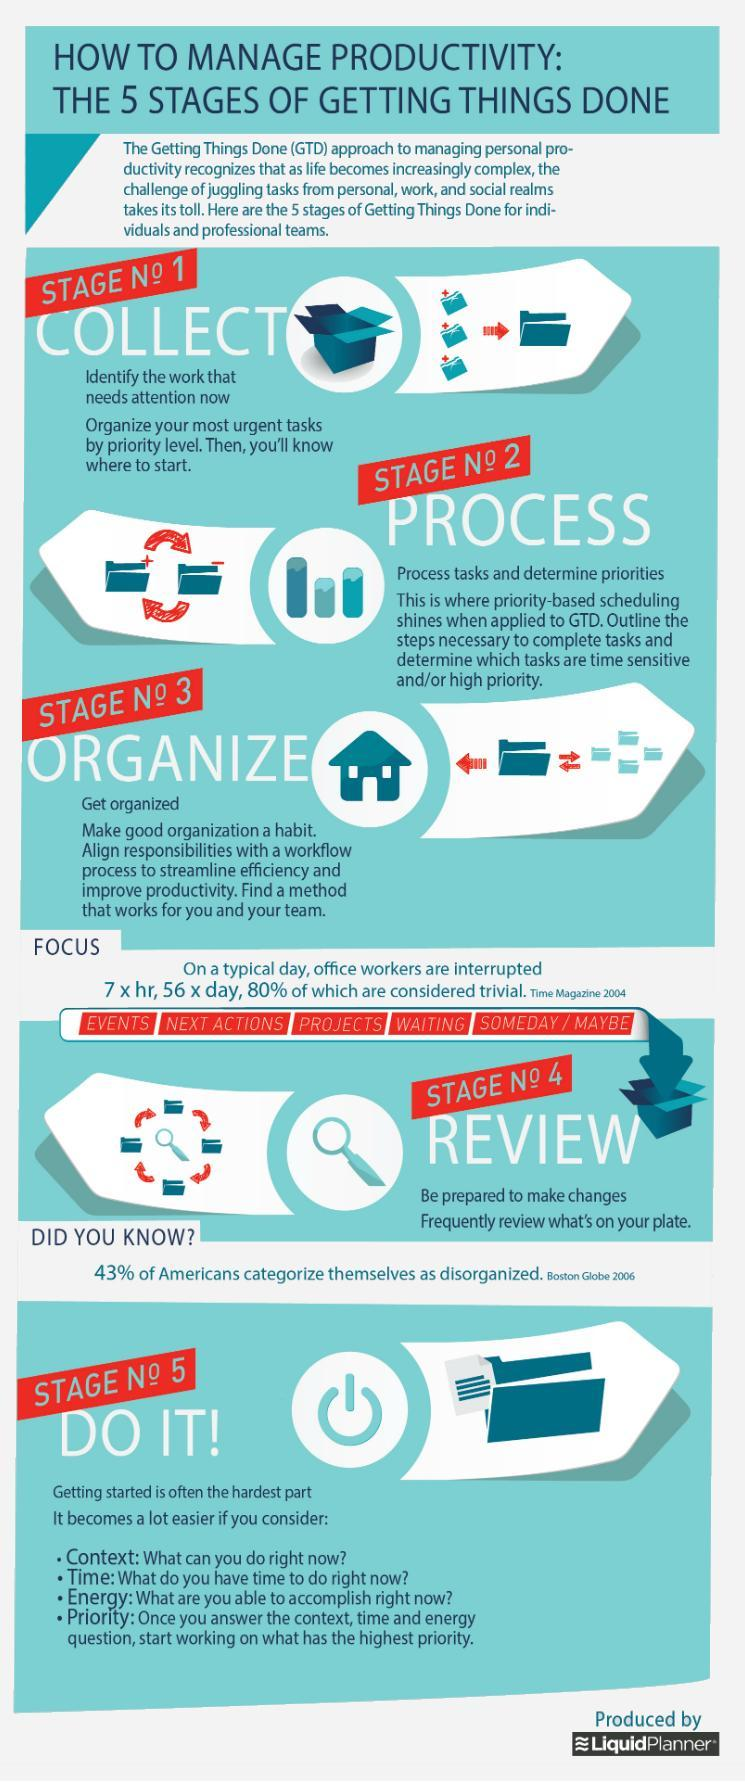What makes it a lot easier to get started?
Answer the question with a short phrase. context,time,energy,priority How many times are office workers interrupted in a work week? 280 